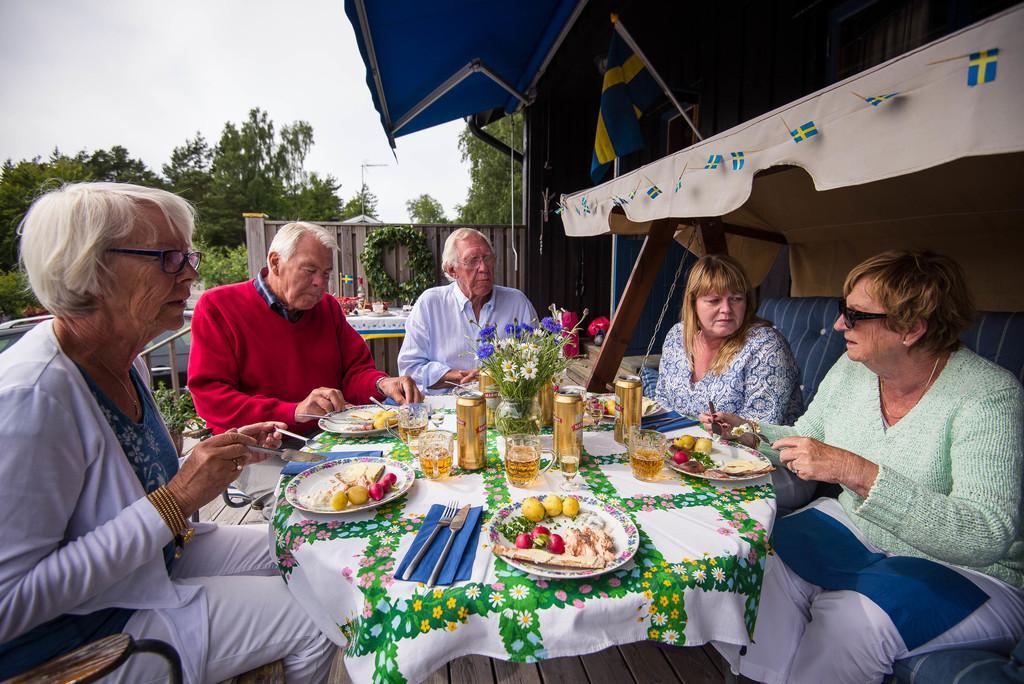Describe this image in one or two sentences. As we can see in the image there are trees, sky, chairs, sofa and a table. On table there is a fork, spoon, knife, plates, tins, glass and fruits. 